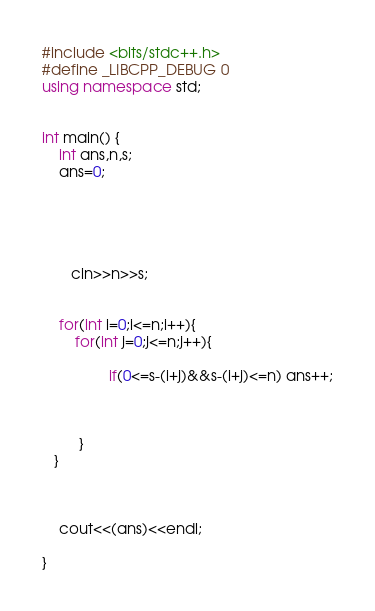<code> <loc_0><loc_0><loc_500><loc_500><_C++_>#include <bits/stdc++.h>
#define _LIBCPP_DEBUG 0
using namespace std;
 

int main() {
    int ans,n,s;
    ans=0;

    
   
    
   
       cin>>n>>s;
       

    for(int i=0;i<=n;i++){
        for(int j=0;j<=n;j++){
            
                if(0<=s-(i+j)&&s-(i+j)<=n) ans++;
            
             
       
         }
   }
   
   

    cout<<(ans)<<endl;

}</code> 